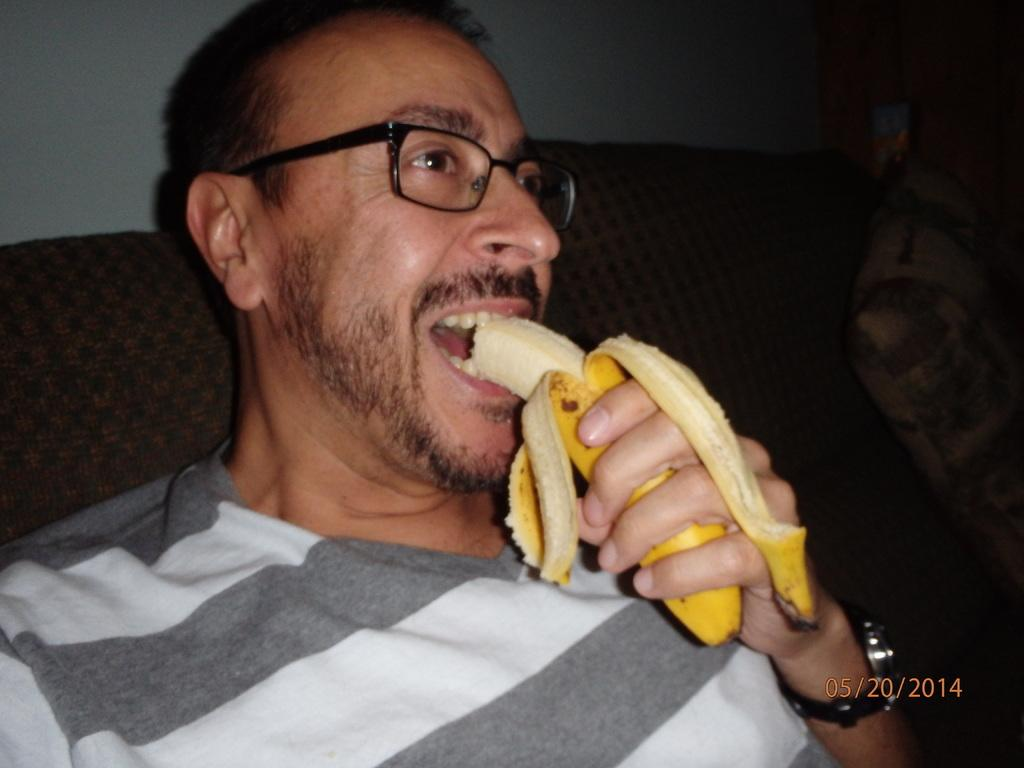What is the man in the image doing? The man is sitting and eating a banana in the image. Can you describe the object on the right side of the image? There is a pillow on the right side of the image. What color is the wall visible in the background of the image? The wall in the background of the image is white. What type of bushes can be seen in the design of the man's shirt in the image? There is no mention of a shirt or any design on the man's clothing in the image, and there are no bushes present. 